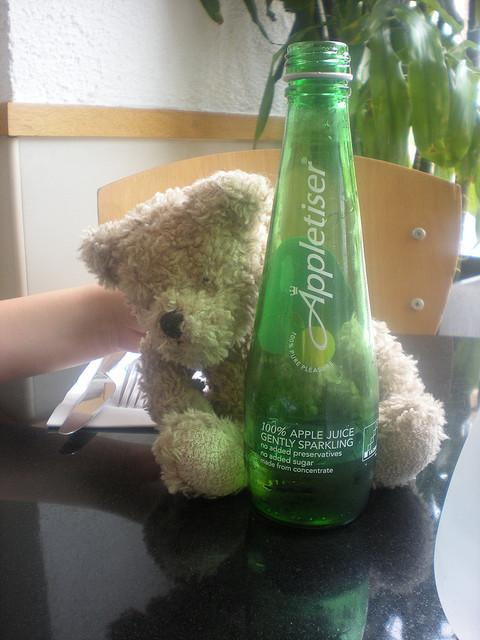What is in the green container? Please explain your reasoning. juice. The bottle says it contains 100% apple juice. 